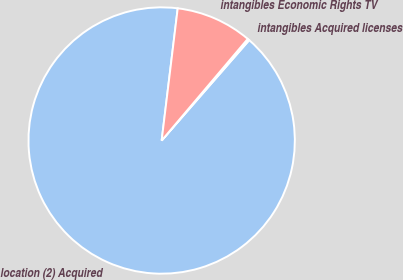<chart> <loc_0><loc_0><loc_500><loc_500><pie_chart><fcel>location (2) Acquired<fcel>intangibles Acquired licenses<fcel>intangibles Economic Rights TV<nl><fcel>90.51%<fcel>0.23%<fcel>9.26%<nl></chart> 